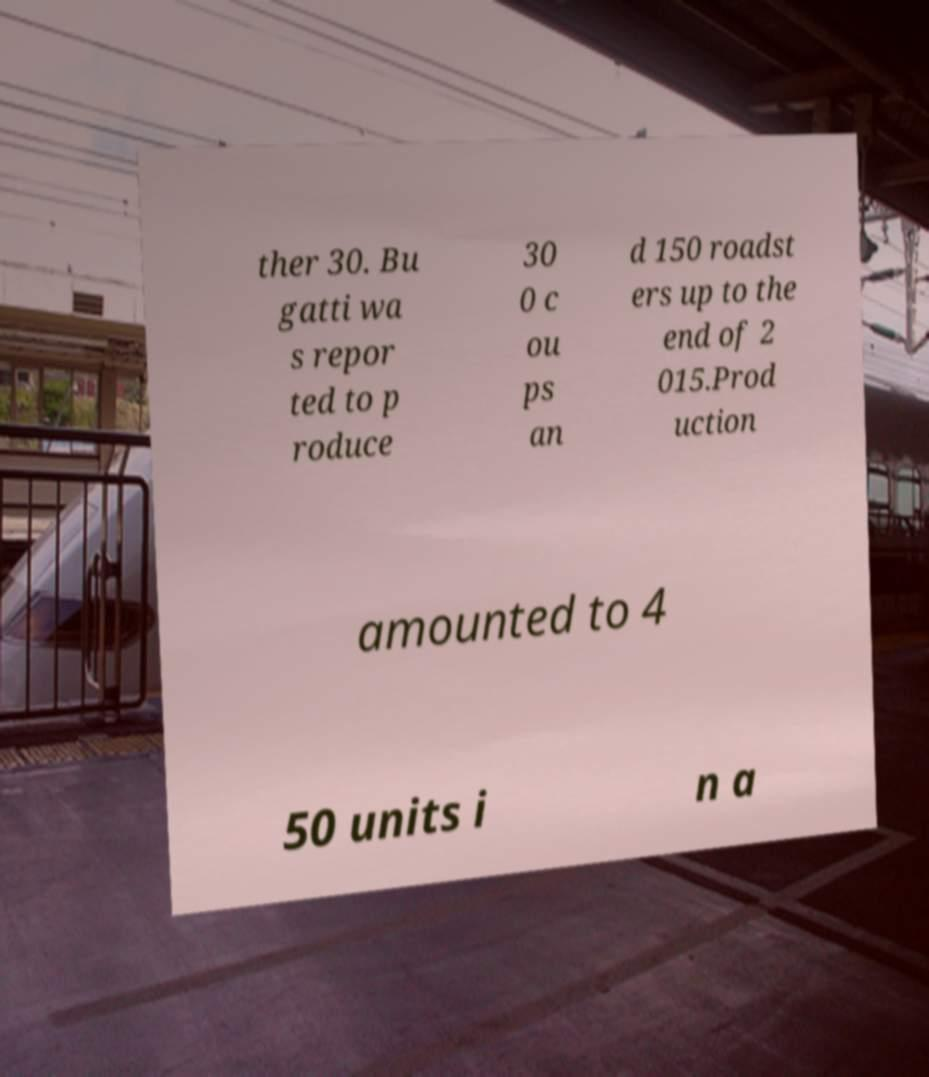I need the written content from this picture converted into text. Can you do that? ther 30. Bu gatti wa s repor ted to p roduce 30 0 c ou ps an d 150 roadst ers up to the end of 2 015.Prod uction amounted to 4 50 units i n a 